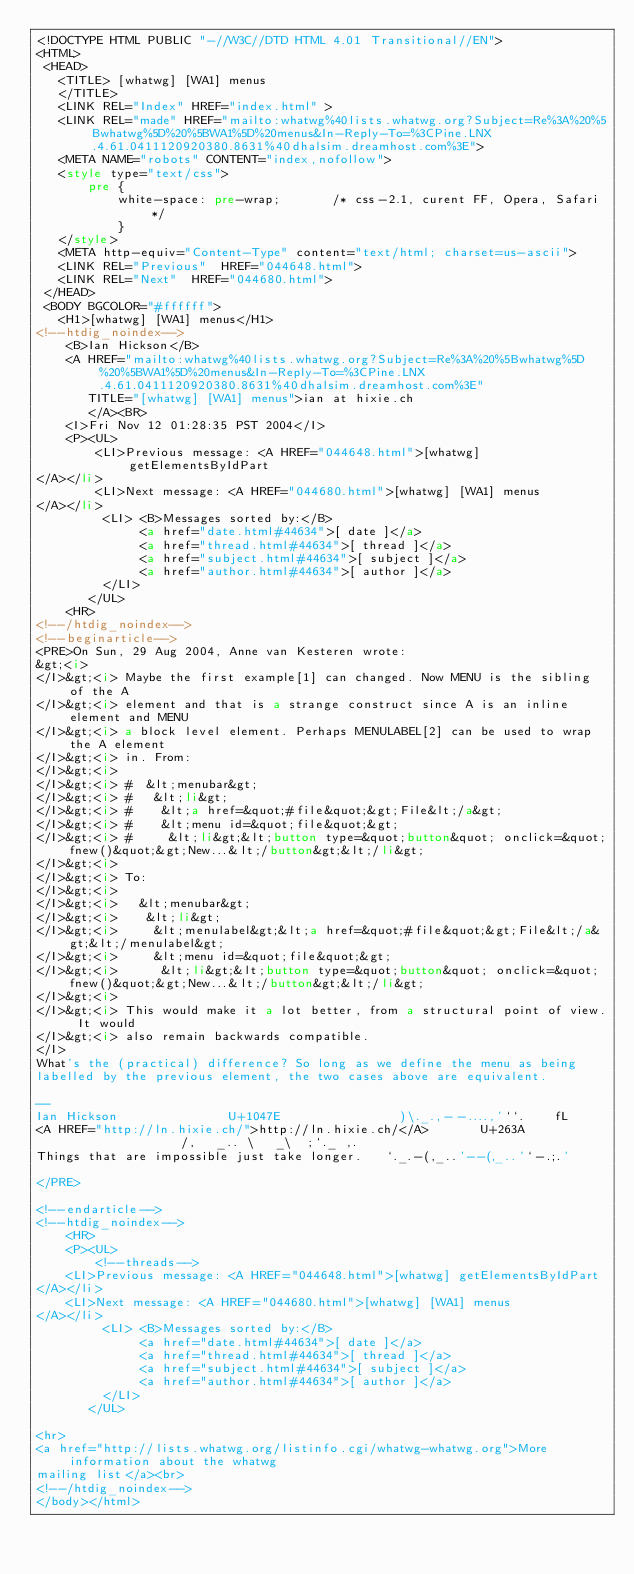<code> <loc_0><loc_0><loc_500><loc_500><_HTML_><!DOCTYPE HTML PUBLIC "-//W3C//DTD HTML 4.01 Transitional//EN">
<HTML>
 <HEAD>
   <TITLE> [whatwg] [WA1] menus
   </TITLE>
   <LINK REL="Index" HREF="index.html" >
   <LINK REL="made" HREF="mailto:whatwg%40lists.whatwg.org?Subject=Re%3A%20%5Bwhatwg%5D%20%5BWA1%5D%20menus&In-Reply-To=%3CPine.LNX.4.61.0411120920380.8631%40dhalsim.dreamhost.com%3E">
   <META NAME="robots" CONTENT="index,nofollow">
   <style type="text/css">
       pre {
           white-space: pre-wrap;       /* css-2.1, curent FF, Opera, Safari */
           }
   </style>
   <META http-equiv="Content-Type" content="text/html; charset=us-ascii">
   <LINK REL="Previous"  HREF="044648.html">
   <LINK REL="Next"  HREF="044680.html">
 </HEAD>
 <BODY BGCOLOR="#ffffff">
   <H1>[whatwg] [WA1] menus</H1>
<!--htdig_noindex-->
    <B>Ian Hickson</B> 
    <A HREF="mailto:whatwg%40lists.whatwg.org?Subject=Re%3A%20%5Bwhatwg%5D%20%5BWA1%5D%20menus&In-Reply-To=%3CPine.LNX.4.61.0411120920380.8631%40dhalsim.dreamhost.com%3E"
       TITLE="[whatwg] [WA1] menus">ian at hixie.ch
       </A><BR>
    <I>Fri Nov 12 01:28:35 PST 2004</I>
    <P><UL>
        <LI>Previous message: <A HREF="044648.html">[whatwg] getElementsByIdPart
</A></li>
        <LI>Next message: <A HREF="044680.html">[whatwg] [WA1] menus
</A></li>
         <LI> <B>Messages sorted by:</B> 
              <a href="date.html#44634">[ date ]</a>
              <a href="thread.html#44634">[ thread ]</a>
              <a href="subject.html#44634">[ subject ]</a>
              <a href="author.html#44634">[ author ]</a>
         </LI>
       </UL>
    <HR>  
<!--/htdig_noindex-->
<!--beginarticle-->
<PRE>On Sun, 29 Aug 2004, Anne van Kesteren wrote:
&gt;<i>
</I>&gt;<i> Maybe the first example[1] can changed. Now MENU is the sibling of the A
</I>&gt;<i> element and that is a strange construct since A is an inline element and MENU
</I>&gt;<i> a block level element. Perhaps MENULABEL[2] can be used to wrap the A element
</I>&gt;<i> in. From:
</I>&gt;<i> 
</I>&gt;<i> #  &lt;menubar&gt;
</I>&gt;<i> #   &lt;li&gt;
</I>&gt;<i> #    &lt;a href=&quot;#file&quot;&gt;File&lt;/a&gt;
</I>&gt;<i> #    &lt;menu id=&quot;file&quot;&gt;
</I>&gt;<i> #     &lt;li&gt;&lt;button type=&quot;button&quot; onclick=&quot;fnew()&quot;&gt;New...&lt;/button&gt;&lt;/li&gt;
</I>&gt;<i> 
</I>&gt;<i> To:
</I>&gt;<i> 
</I>&gt;<i>   &lt;menubar&gt;
</I>&gt;<i>    &lt;li&gt;
</I>&gt;<i>     &lt;menulabel&gt;&lt;a href=&quot;#file&quot;&gt;File&lt;/a&gt;&lt;/menulabel&gt;
</I>&gt;<i>     &lt;menu id=&quot;file&quot;&gt;
</I>&gt;<i>      &lt;li&gt;&lt;button type=&quot;button&quot; onclick=&quot;fnew()&quot;&gt;New...&lt;/button&gt;&lt;/li&gt;
</I>&gt;<i> 
</I>&gt;<i> This would make it a lot better, from a structural point of view. It would
</I>&gt;<i> also remain backwards compatible.
</I>
What's the (practical) difference? So long as we define the menu as being 
labelled by the previous element, the two cases above are equivalent.

-- 
Ian Hickson               U+1047E                )\._.,--....,'``.    fL
<A HREF="http://ln.hixie.ch/">http://ln.hixie.ch/</A>       U+263A                /,   _.. \   _\  ;`._ ,.
Things that are impossible just take longer.   `._.-(,_..'--(,_..'`-.;.'

</PRE>

<!--endarticle-->
<!--htdig_noindex-->
    <HR>
    <P><UL>
        <!--threads-->
	<LI>Previous message: <A HREF="044648.html">[whatwg] getElementsByIdPart
</A></li>
	<LI>Next message: <A HREF="044680.html">[whatwg] [WA1] menus
</A></li>
         <LI> <B>Messages sorted by:</B> 
              <a href="date.html#44634">[ date ]</a>
              <a href="thread.html#44634">[ thread ]</a>
              <a href="subject.html#44634">[ subject ]</a>
              <a href="author.html#44634">[ author ]</a>
         </LI>
       </UL>

<hr>
<a href="http://lists.whatwg.org/listinfo.cgi/whatwg-whatwg.org">More information about the whatwg
mailing list</a><br>
<!--/htdig_noindex-->
</body></html>
</code> 